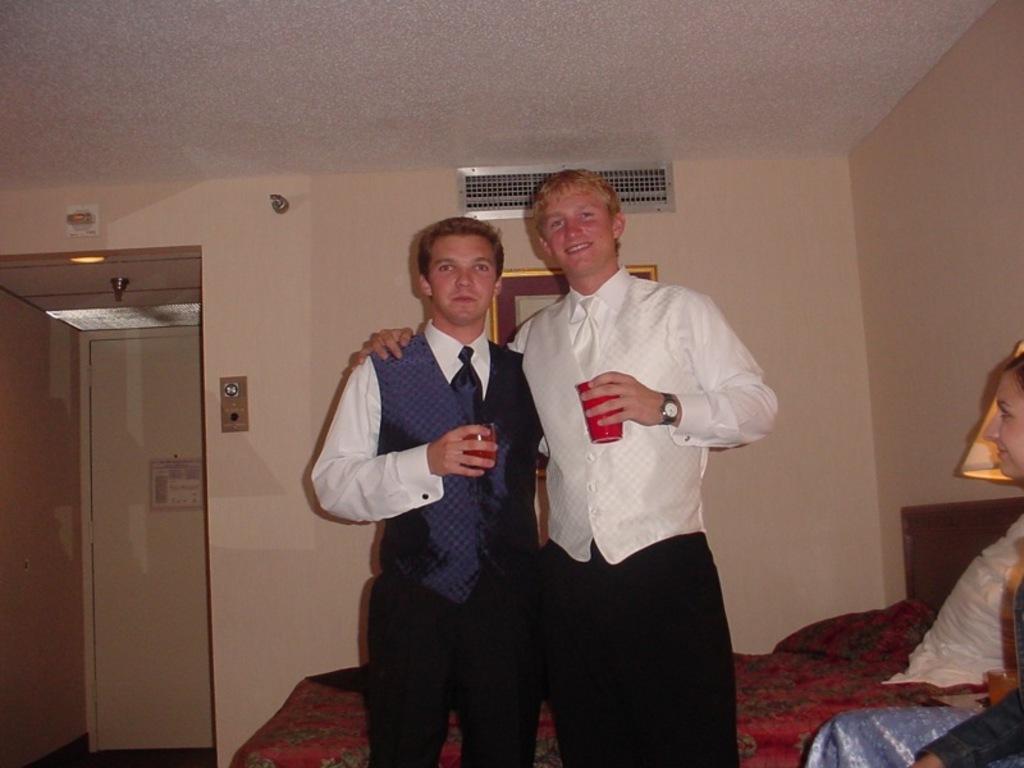Please provide a concise description of this image. In this image in the center there are persons standing and smiling and holding glass in their hands. On the right side there is a woman sitting and smiling and there is a light lamp and there is a pillow on the bed which is in the background and there is a door in the background. On the top there is a light and there is a ventilator and there is is a frame on the wall which is in the background. 